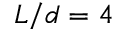Convert formula to latex. <formula><loc_0><loc_0><loc_500><loc_500>L / d = 4</formula> 